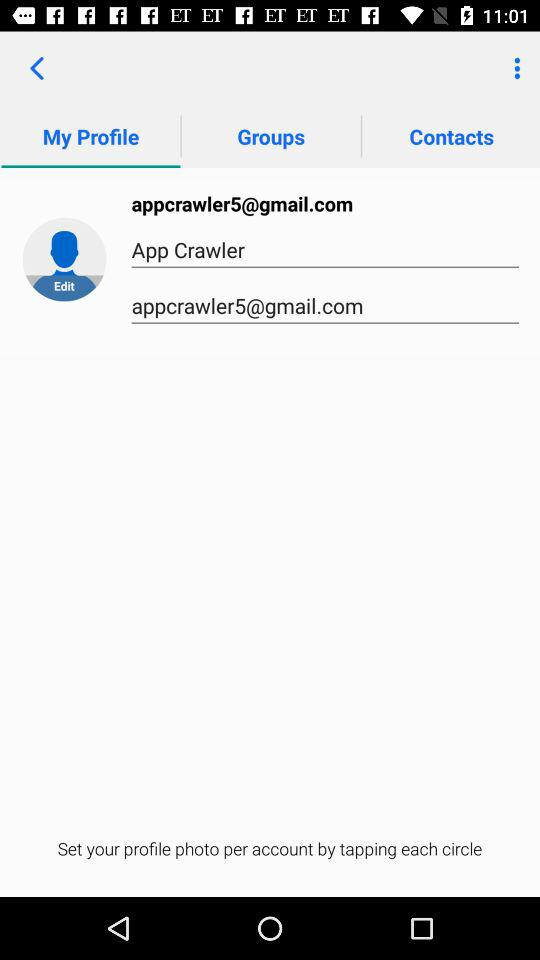What is the user name? The user name is App Crawler. 